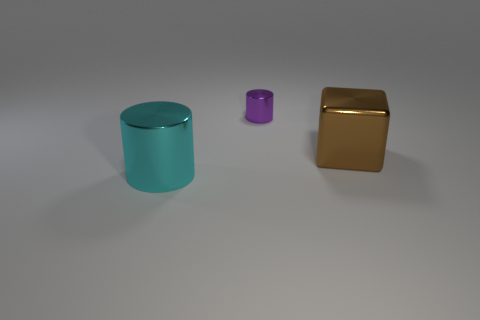How does the texture of the golden object compare to the other objects? The golden object has a smooth and reflective surface that gives it a shiny appearance, while the cyan and purple objects have a more matte finish, making them less reflective. 